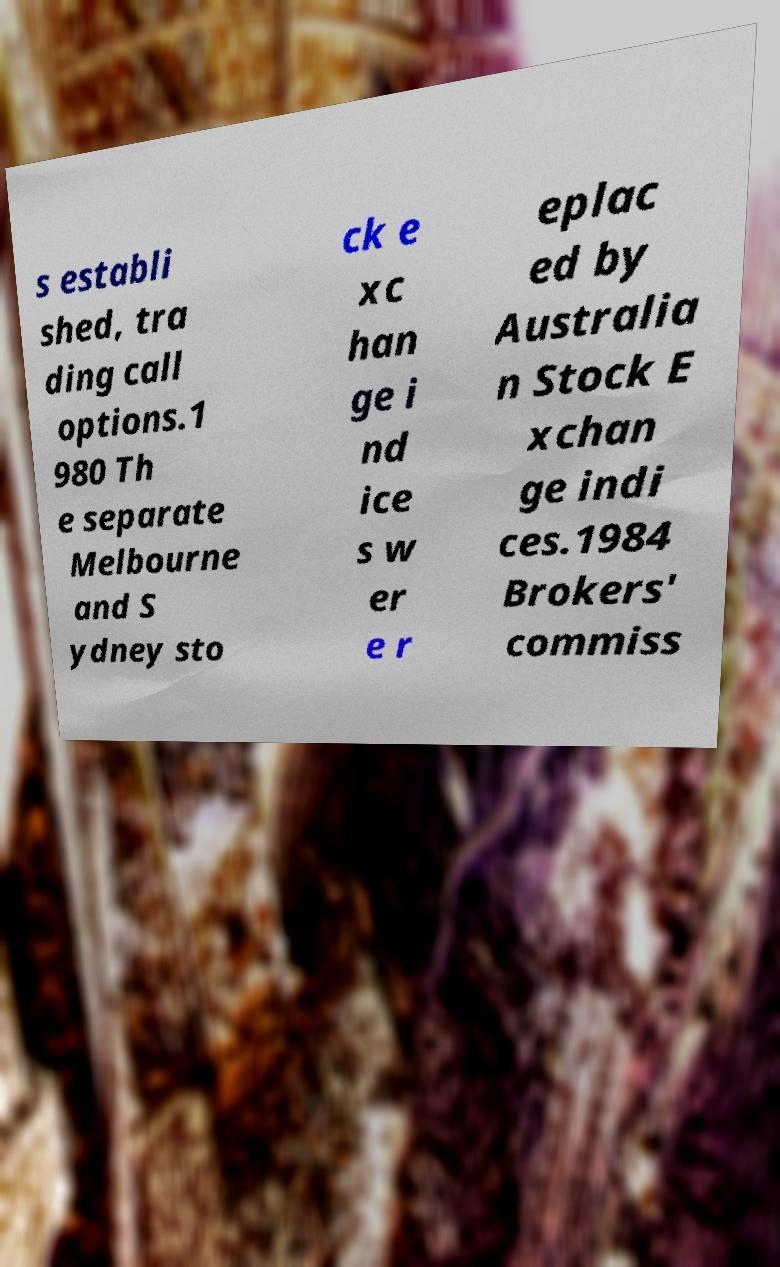Can you accurately transcribe the text from the provided image for me? s establi shed, tra ding call options.1 980 Th e separate Melbourne and S ydney sto ck e xc han ge i nd ice s w er e r eplac ed by Australia n Stock E xchan ge indi ces.1984 Brokers' commiss 